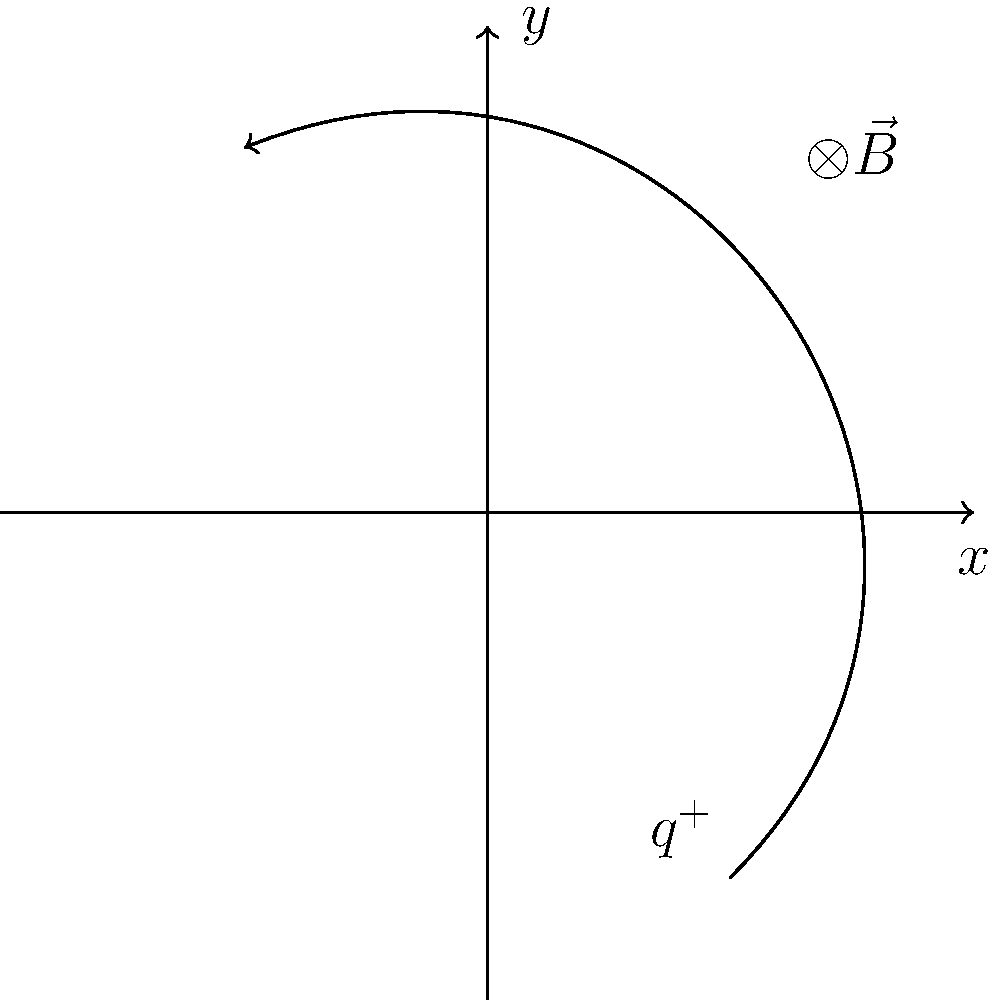A positively charged particle enters a uniform magnetic field perpendicular to its initial velocity. The magnetic field is directed into the page, as shown by the $\otimes$ symbol. Given that the particle's trajectory is curved as depicted in the diagram, determine the direction of the magnetic force acting on the particle at the point where it crosses the y-axis. How does this relate to the particle's velocity at that instant? To determine the direction of the magnetic force and its relation to the particle's velocity, we'll follow these steps:

1) Recall the right-hand rule for magnetic force: $\vec{F} = q(\vec{v} \times \vec{B})$

2) At the point where the particle crosses the y-axis:
   - The magnetic field $\vec{B}$ is into the page (negative z-direction)
   - The velocity $\vec{v}$ is tangent to the curve, pointing upward and slightly to the left

3) Applying the right-hand rule:
   - Point your fingers in the direction of $\vec{v}$ (upward and slightly left)
   - Curl them into the direction of $\vec{B}$ (into the page)
   - Your thumb points in the direction of $\vec{F}$ for a positive charge

4) The result shows that the magnetic force is pointing to the left (negative x-direction)

5) The force is perpendicular to both $\vec{v}$ and $\vec{B}$, which is consistent with the cross product in the equation $\vec{F} = q(\vec{v} \times \vec{B})$

6) This perpendicular force causes the circular motion of the charged particle in the magnetic field

7) The force is always perpendicular to the velocity, which means it continuously changes the direction of the velocity without changing its magnitude

This analysis demonstrates how molecular dynamics principles, such as the interaction between charged particles and fields, can be observed and quantified, providing insights for developing tools to study similar phenomena at the molecular level.
Answer: The magnetic force acts to the left (negative x-direction), perpendicular to both the velocity and magnetic field. 